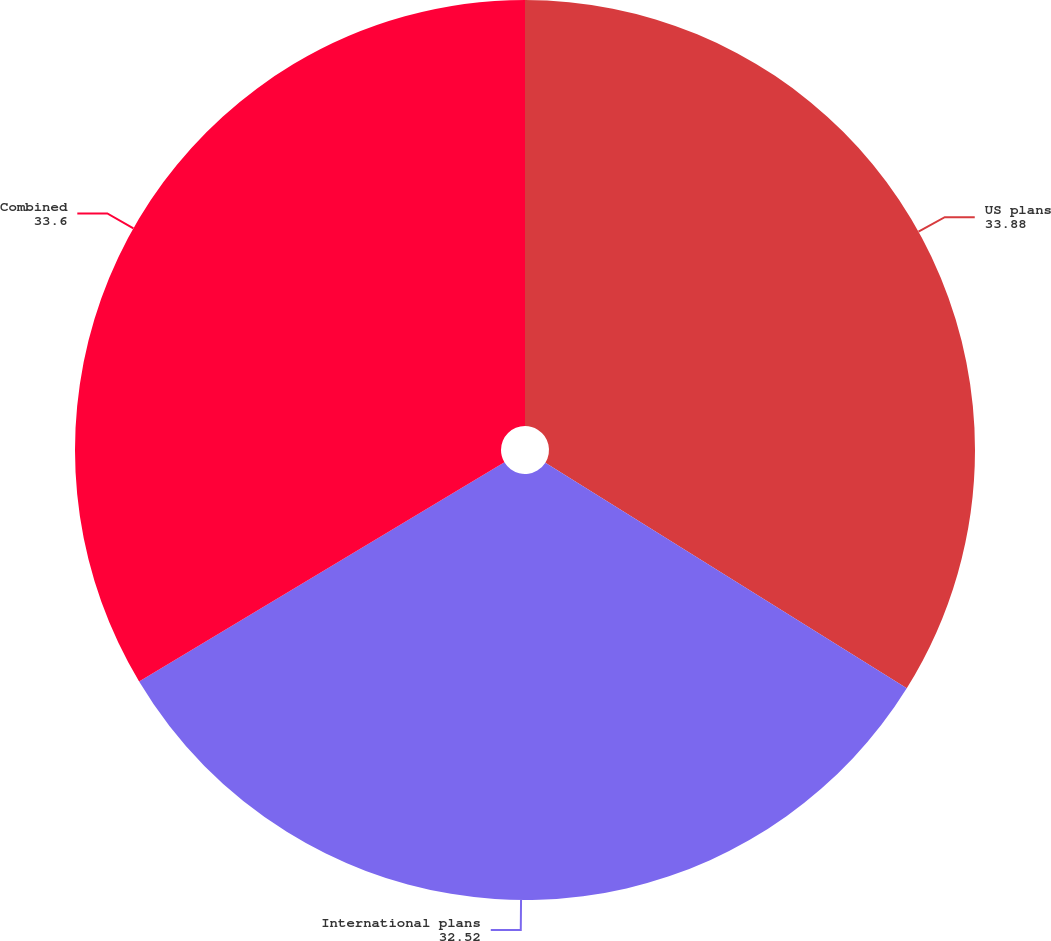Convert chart. <chart><loc_0><loc_0><loc_500><loc_500><pie_chart><fcel>US plans<fcel>International plans<fcel>Combined<nl><fcel>33.88%<fcel>32.52%<fcel>33.6%<nl></chart> 